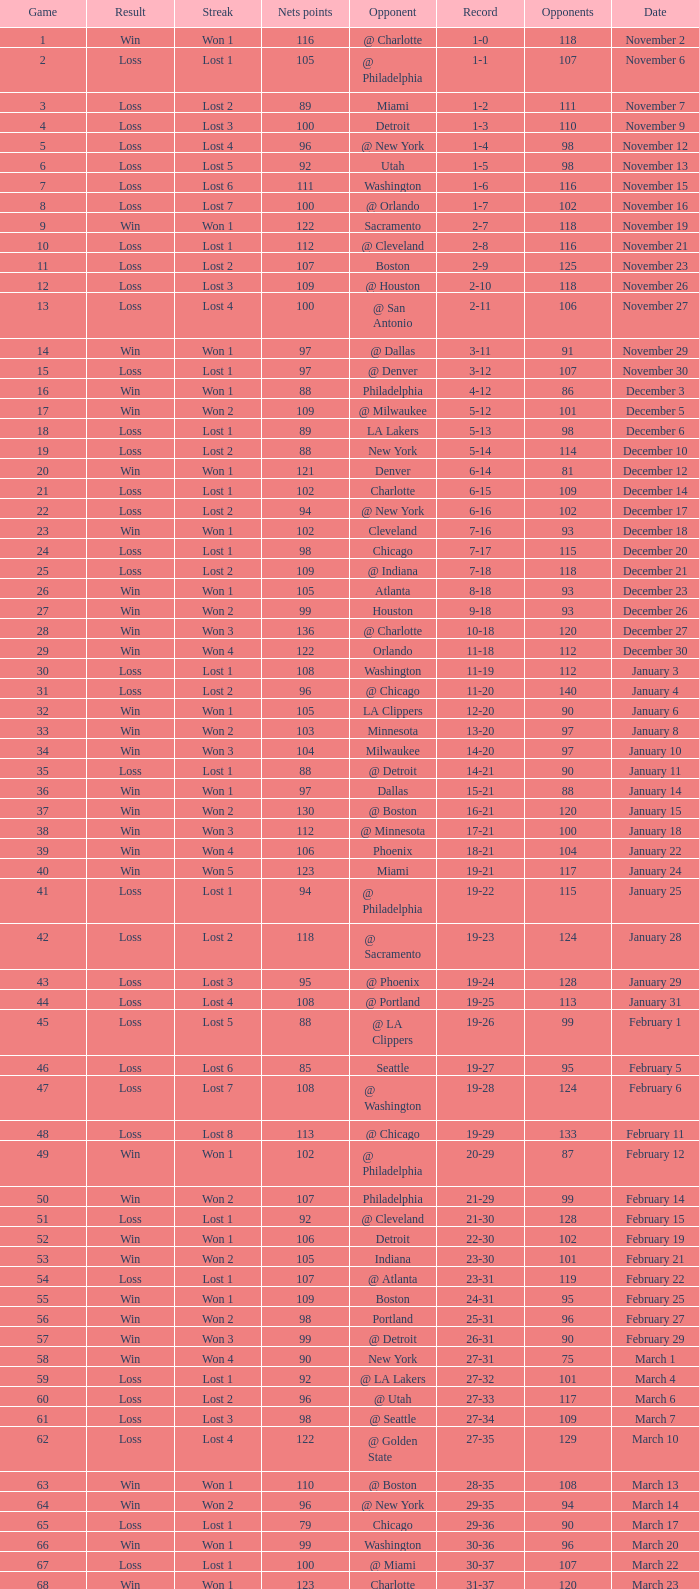Which opponent is from february 12? @ Philadelphia. 